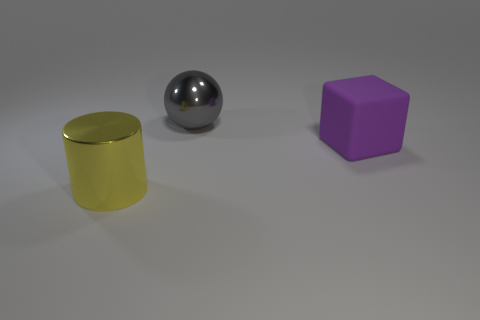Add 2 purple rubber cubes. How many objects exist? 5 Subtract all cubes. How many objects are left? 2 Add 1 large brown cubes. How many large brown cubes exist? 1 Subtract 0 blue spheres. How many objects are left? 3 Subtract all large purple rubber things. Subtract all large balls. How many objects are left? 1 Add 2 gray metal things. How many gray metal things are left? 3 